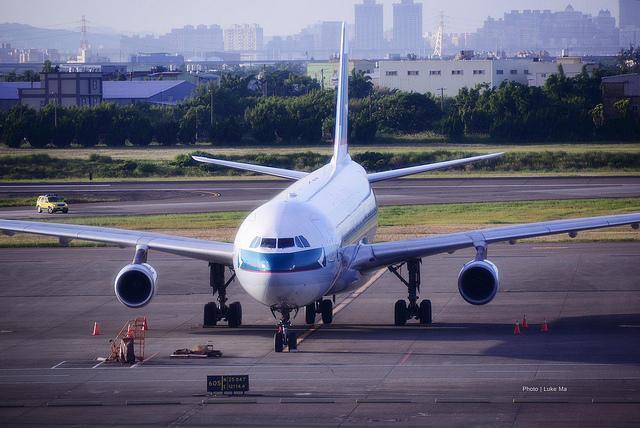How many horses are there?
Give a very brief answer. 0. 